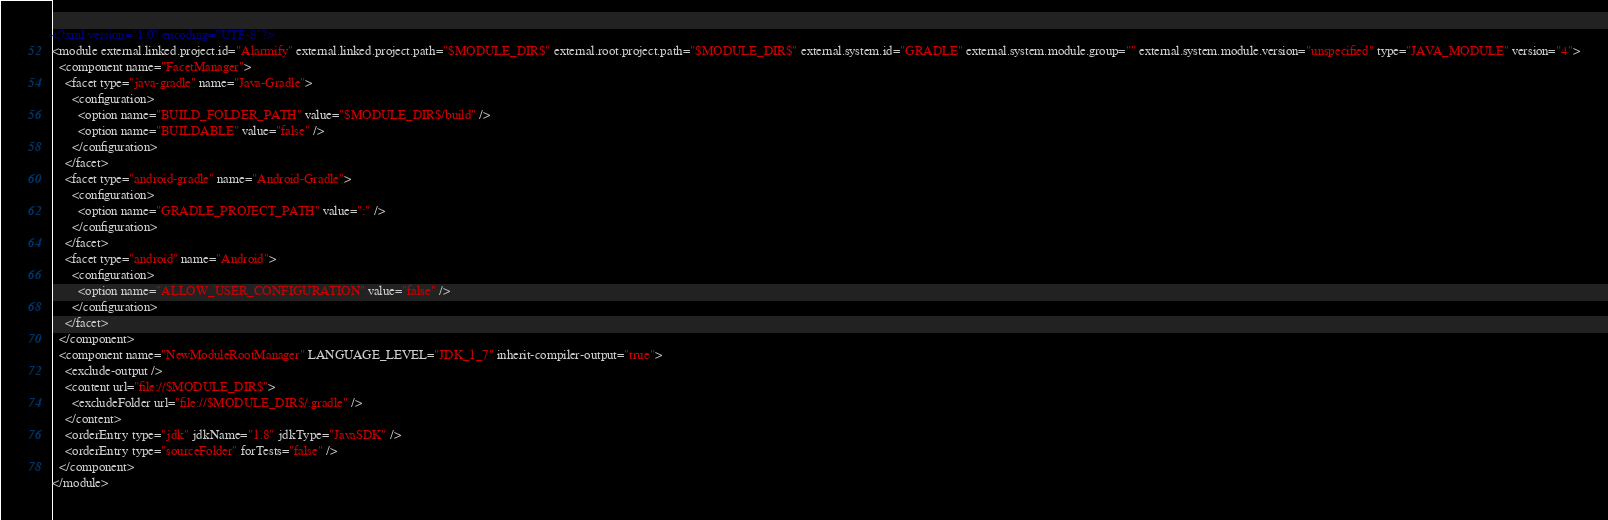<code> <loc_0><loc_0><loc_500><loc_500><_XML_><?xml version="1.0" encoding="UTF-8"?>
<module external.linked.project.id="Alarmify" external.linked.project.path="$MODULE_DIR$" external.root.project.path="$MODULE_DIR$" external.system.id="GRADLE" external.system.module.group="" external.system.module.version="unspecified" type="JAVA_MODULE" version="4">
  <component name="FacetManager">
    <facet type="java-gradle" name="Java-Gradle">
      <configuration>
        <option name="BUILD_FOLDER_PATH" value="$MODULE_DIR$/build" />
        <option name="BUILDABLE" value="false" />
      </configuration>
    </facet>
    <facet type="android-gradle" name="Android-Gradle">
      <configuration>
        <option name="GRADLE_PROJECT_PATH" value=":" />
      </configuration>
    </facet>
    <facet type="android" name="Android">
      <configuration>
        <option name="ALLOW_USER_CONFIGURATION" value="false" />
      </configuration>
    </facet>
  </component>
  <component name="NewModuleRootManager" LANGUAGE_LEVEL="JDK_1_7" inherit-compiler-output="true">
    <exclude-output />
    <content url="file://$MODULE_DIR$">
      <excludeFolder url="file://$MODULE_DIR$/.gradle" />
    </content>
    <orderEntry type="jdk" jdkName="1.8" jdkType="JavaSDK" />
    <orderEntry type="sourceFolder" forTests="false" />
  </component>
</module></code> 